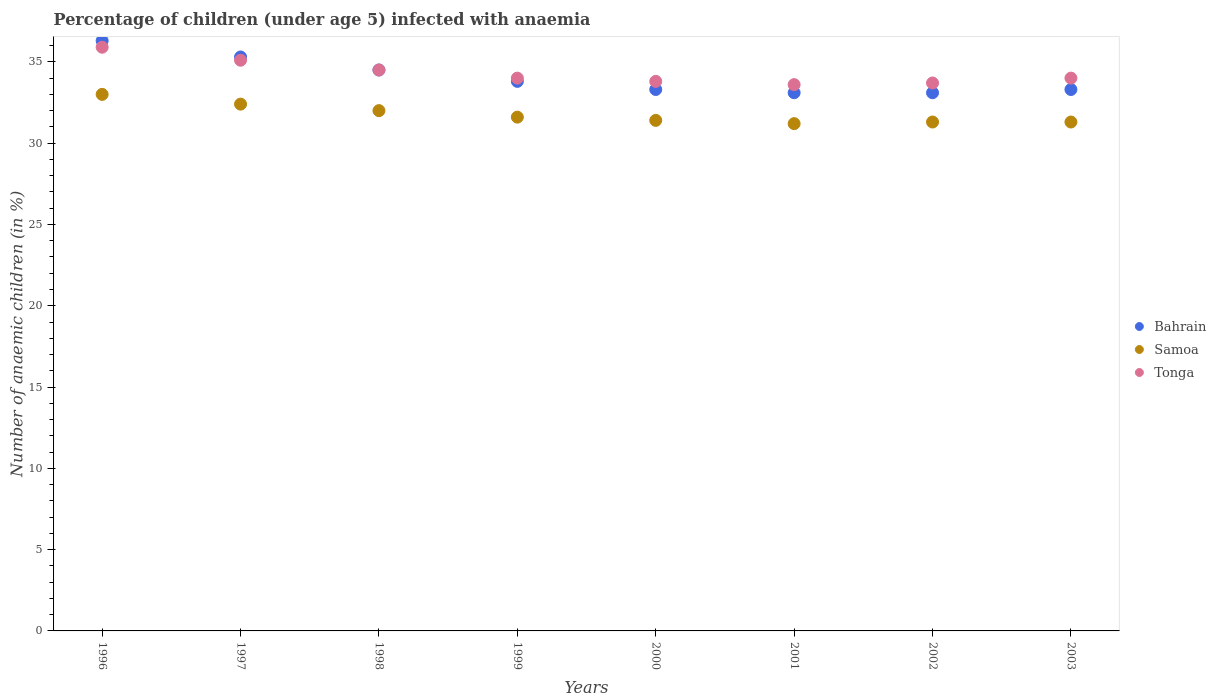What is the percentage of children infected with anaemia in in Bahrain in 1999?
Keep it short and to the point. 33.8. Across all years, what is the minimum percentage of children infected with anaemia in in Tonga?
Provide a short and direct response. 33.6. In which year was the percentage of children infected with anaemia in in Samoa maximum?
Provide a succinct answer. 1996. What is the total percentage of children infected with anaemia in in Bahrain in the graph?
Your answer should be very brief. 272.7. What is the difference between the percentage of children infected with anaemia in in Bahrain in 1996 and that in 1999?
Your answer should be very brief. 2.5. What is the difference between the percentage of children infected with anaemia in in Tonga in 1998 and the percentage of children infected with anaemia in in Samoa in 1997?
Ensure brevity in your answer.  2.1. What is the average percentage of children infected with anaemia in in Samoa per year?
Give a very brief answer. 31.77. In the year 2002, what is the difference between the percentage of children infected with anaemia in in Samoa and percentage of children infected with anaemia in in Tonga?
Offer a very short reply. -2.4. What is the ratio of the percentage of children infected with anaemia in in Bahrain in 1996 to that in 2003?
Your response must be concise. 1.09. Is the percentage of children infected with anaemia in in Bahrain in 1999 less than that in 2000?
Your answer should be compact. No. Is the difference between the percentage of children infected with anaemia in in Samoa in 1996 and 1998 greater than the difference between the percentage of children infected with anaemia in in Tonga in 1996 and 1998?
Make the answer very short. No. What is the difference between the highest and the second highest percentage of children infected with anaemia in in Bahrain?
Provide a succinct answer. 1. What is the difference between the highest and the lowest percentage of children infected with anaemia in in Bahrain?
Ensure brevity in your answer.  3.2. In how many years, is the percentage of children infected with anaemia in in Bahrain greater than the average percentage of children infected with anaemia in in Bahrain taken over all years?
Your answer should be very brief. 3. Is the sum of the percentage of children infected with anaemia in in Tonga in 1997 and 2000 greater than the maximum percentage of children infected with anaemia in in Samoa across all years?
Offer a very short reply. Yes. Does the percentage of children infected with anaemia in in Tonga monotonically increase over the years?
Your answer should be compact. No. Is the percentage of children infected with anaemia in in Tonga strictly less than the percentage of children infected with anaemia in in Bahrain over the years?
Offer a very short reply. No. What is the difference between two consecutive major ticks on the Y-axis?
Provide a succinct answer. 5. Are the values on the major ticks of Y-axis written in scientific E-notation?
Your answer should be very brief. No. Does the graph contain grids?
Give a very brief answer. No. How many legend labels are there?
Provide a succinct answer. 3. How are the legend labels stacked?
Your answer should be very brief. Vertical. What is the title of the graph?
Ensure brevity in your answer.  Percentage of children (under age 5) infected with anaemia. Does "Caribbean small states" appear as one of the legend labels in the graph?
Your answer should be compact. No. What is the label or title of the Y-axis?
Ensure brevity in your answer.  Number of anaemic children (in %). What is the Number of anaemic children (in %) in Bahrain in 1996?
Your response must be concise. 36.3. What is the Number of anaemic children (in %) of Samoa in 1996?
Your answer should be compact. 33. What is the Number of anaemic children (in %) in Tonga in 1996?
Give a very brief answer. 35.9. What is the Number of anaemic children (in %) in Bahrain in 1997?
Make the answer very short. 35.3. What is the Number of anaemic children (in %) in Samoa in 1997?
Your response must be concise. 32.4. What is the Number of anaemic children (in %) of Tonga in 1997?
Make the answer very short. 35.1. What is the Number of anaemic children (in %) in Bahrain in 1998?
Your answer should be compact. 34.5. What is the Number of anaemic children (in %) of Samoa in 1998?
Offer a terse response. 32. What is the Number of anaemic children (in %) of Tonga in 1998?
Ensure brevity in your answer.  34.5. What is the Number of anaemic children (in %) of Bahrain in 1999?
Give a very brief answer. 33.8. What is the Number of anaemic children (in %) of Samoa in 1999?
Keep it short and to the point. 31.6. What is the Number of anaemic children (in %) of Bahrain in 2000?
Make the answer very short. 33.3. What is the Number of anaemic children (in %) of Samoa in 2000?
Give a very brief answer. 31.4. What is the Number of anaemic children (in %) of Tonga in 2000?
Provide a succinct answer. 33.8. What is the Number of anaemic children (in %) in Bahrain in 2001?
Your answer should be very brief. 33.1. What is the Number of anaemic children (in %) of Samoa in 2001?
Offer a very short reply. 31.2. What is the Number of anaemic children (in %) of Tonga in 2001?
Ensure brevity in your answer.  33.6. What is the Number of anaemic children (in %) of Bahrain in 2002?
Provide a short and direct response. 33.1. What is the Number of anaemic children (in %) of Samoa in 2002?
Offer a terse response. 31.3. What is the Number of anaemic children (in %) of Tonga in 2002?
Your response must be concise. 33.7. What is the Number of anaemic children (in %) of Bahrain in 2003?
Your response must be concise. 33.3. What is the Number of anaemic children (in %) in Samoa in 2003?
Provide a short and direct response. 31.3. What is the Number of anaemic children (in %) in Tonga in 2003?
Offer a terse response. 34. Across all years, what is the maximum Number of anaemic children (in %) in Bahrain?
Provide a succinct answer. 36.3. Across all years, what is the maximum Number of anaemic children (in %) of Samoa?
Make the answer very short. 33. Across all years, what is the maximum Number of anaemic children (in %) in Tonga?
Ensure brevity in your answer.  35.9. Across all years, what is the minimum Number of anaemic children (in %) of Bahrain?
Your answer should be very brief. 33.1. Across all years, what is the minimum Number of anaemic children (in %) in Samoa?
Give a very brief answer. 31.2. Across all years, what is the minimum Number of anaemic children (in %) of Tonga?
Provide a succinct answer. 33.6. What is the total Number of anaemic children (in %) of Bahrain in the graph?
Offer a terse response. 272.7. What is the total Number of anaemic children (in %) of Samoa in the graph?
Provide a short and direct response. 254.2. What is the total Number of anaemic children (in %) of Tonga in the graph?
Keep it short and to the point. 274.6. What is the difference between the Number of anaemic children (in %) in Bahrain in 1996 and that in 1997?
Your answer should be compact. 1. What is the difference between the Number of anaemic children (in %) of Samoa in 1996 and that in 1997?
Your answer should be very brief. 0.6. What is the difference between the Number of anaemic children (in %) of Samoa in 1996 and that in 1998?
Keep it short and to the point. 1. What is the difference between the Number of anaemic children (in %) of Bahrain in 1996 and that in 1999?
Your answer should be very brief. 2.5. What is the difference between the Number of anaemic children (in %) of Tonga in 1996 and that in 1999?
Your response must be concise. 1.9. What is the difference between the Number of anaemic children (in %) of Bahrain in 1996 and that in 2000?
Keep it short and to the point. 3. What is the difference between the Number of anaemic children (in %) of Samoa in 1996 and that in 2000?
Offer a very short reply. 1.6. What is the difference between the Number of anaemic children (in %) in Bahrain in 1996 and that in 2001?
Keep it short and to the point. 3.2. What is the difference between the Number of anaemic children (in %) in Samoa in 1996 and that in 2001?
Your answer should be very brief. 1.8. What is the difference between the Number of anaemic children (in %) of Bahrain in 1996 and that in 2002?
Your response must be concise. 3.2. What is the difference between the Number of anaemic children (in %) in Tonga in 1997 and that in 1998?
Give a very brief answer. 0.6. What is the difference between the Number of anaemic children (in %) of Samoa in 1997 and that in 1999?
Your answer should be very brief. 0.8. What is the difference between the Number of anaemic children (in %) in Tonga in 1997 and that in 1999?
Offer a terse response. 1.1. What is the difference between the Number of anaemic children (in %) in Bahrain in 1997 and that in 2000?
Offer a very short reply. 2. What is the difference between the Number of anaemic children (in %) of Samoa in 1997 and that in 2000?
Your response must be concise. 1. What is the difference between the Number of anaemic children (in %) in Bahrain in 1997 and that in 2001?
Ensure brevity in your answer.  2.2. What is the difference between the Number of anaemic children (in %) of Samoa in 1997 and that in 2001?
Give a very brief answer. 1.2. What is the difference between the Number of anaemic children (in %) of Tonga in 1997 and that in 2001?
Keep it short and to the point. 1.5. What is the difference between the Number of anaemic children (in %) of Bahrain in 1997 and that in 2002?
Provide a succinct answer. 2.2. What is the difference between the Number of anaemic children (in %) in Samoa in 1997 and that in 2002?
Keep it short and to the point. 1.1. What is the difference between the Number of anaemic children (in %) of Tonga in 1997 and that in 2002?
Keep it short and to the point. 1.4. What is the difference between the Number of anaemic children (in %) in Bahrain in 1997 and that in 2003?
Your answer should be very brief. 2. What is the difference between the Number of anaemic children (in %) of Samoa in 1997 and that in 2003?
Give a very brief answer. 1.1. What is the difference between the Number of anaemic children (in %) of Tonga in 1997 and that in 2003?
Offer a terse response. 1.1. What is the difference between the Number of anaemic children (in %) of Bahrain in 1998 and that in 1999?
Your answer should be very brief. 0.7. What is the difference between the Number of anaemic children (in %) of Bahrain in 1998 and that in 2000?
Your answer should be compact. 1.2. What is the difference between the Number of anaemic children (in %) of Tonga in 1998 and that in 2000?
Give a very brief answer. 0.7. What is the difference between the Number of anaemic children (in %) of Bahrain in 1998 and that in 2001?
Offer a very short reply. 1.4. What is the difference between the Number of anaemic children (in %) of Samoa in 1998 and that in 2001?
Provide a short and direct response. 0.8. What is the difference between the Number of anaemic children (in %) of Tonga in 1998 and that in 2001?
Keep it short and to the point. 0.9. What is the difference between the Number of anaemic children (in %) in Bahrain in 1998 and that in 2002?
Your answer should be compact. 1.4. What is the difference between the Number of anaemic children (in %) of Samoa in 1998 and that in 2002?
Your answer should be very brief. 0.7. What is the difference between the Number of anaemic children (in %) in Tonga in 1998 and that in 2002?
Your answer should be compact. 0.8. What is the difference between the Number of anaemic children (in %) of Bahrain in 1999 and that in 2000?
Ensure brevity in your answer.  0.5. What is the difference between the Number of anaemic children (in %) of Samoa in 1999 and that in 2000?
Your response must be concise. 0.2. What is the difference between the Number of anaemic children (in %) in Tonga in 1999 and that in 2000?
Your answer should be very brief. 0.2. What is the difference between the Number of anaemic children (in %) in Bahrain in 1999 and that in 2001?
Make the answer very short. 0.7. What is the difference between the Number of anaemic children (in %) in Samoa in 1999 and that in 2002?
Offer a terse response. 0.3. What is the difference between the Number of anaemic children (in %) of Tonga in 1999 and that in 2002?
Your answer should be compact. 0.3. What is the difference between the Number of anaemic children (in %) of Samoa in 1999 and that in 2003?
Give a very brief answer. 0.3. What is the difference between the Number of anaemic children (in %) of Tonga in 2000 and that in 2001?
Give a very brief answer. 0.2. What is the difference between the Number of anaemic children (in %) of Bahrain in 2000 and that in 2002?
Make the answer very short. 0.2. What is the difference between the Number of anaemic children (in %) of Bahrain in 2000 and that in 2003?
Give a very brief answer. 0. What is the difference between the Number of anaemic children (in %) in Samoa in 2000 and that in 2003?
Your answer should be very brief. 0.1. What is the difference between the Number of anaemic children (in %) in Bahrain in 2001 and that in 2002?
Offer a very short reply. 0. What is the difference between the Number of anaemic children (in %) of Tonga in 2001 and that in 2002?
Offer a terse response. -0.1. What is the difference between the Number of anaemic children (in %) in Samoa in 2001 and that in 2003?
Provide a short and direct response. -0.1. What is the difference between the Number of anaemic children (in %) in Bahrain in 2002 and that in 2003?
Make the answer very short. -0.2. What is the difference between the Number of anaemic children (in %) in Samoa in 2002 and that in 2003?
Keep it short and to the point. 0. What is the difference between the Number of anaemic children (in %) in Tonga in 2002 and that in 2003?
Give a very brief answer. -0.3. What is the difference between the Number of anaemic children (in %) in Bahrain in 1996 and the Number of anaemic children (in %) in Tonga in 1997?
Your response must be concise. 1.2. What is the difference between the Number of anaemic children (in %) of Bahrain in 1996 and the Number of anaemic children (in %) of Samoa in 1998?
Offer a very short reply. 4.3. What is the difference between the Number of anaemic children (in %) of Samoa in 1996 and the Number of anaemic children (in %) of Tonga in 1998?
Keep it short and to the point. -1.5. What is the difference between the Number of anaemic children (in %) in Samoa in 1996 and the Number of anaemic children (in %) in Tonga in 2000?
Your answer should be very brief. -0.8. What is the difference between the Number of anaemic children (in %) in Samoa in 1996 and the Number of anaemic children (in %) in Tonga in 2002?
Offer a terse response. -0.7. What is the difference between the Number of anaemic children (in %) in Samoa in 1996 and the Number of anaemic children (in %) in Tonga in 2003?
Your answer should be very brief. -1. What is the difference between the Number of anaemic children (in %) in Bahrain in 1997 and the Number of anaemic children (in %) in Tonga in 1998?
Provide a succinct answer. 0.8. What is the difference between the Number of anaemic children (in %) of Samoa in 1997 and the Number of anaemic children (in %) of Tonga in 1998?
Keep it short and to the point. -2.1. What is the difference between the Number of anaemic children (in %) of Bahrain in 1997 and the Number of anaemic children (in %) of Tonga in 1999?
Provide a succinct answer. 1.3. What is the difference between the Number of anaemic children (in %) of Samoa in 1997 and the Number of anaemic children (in %) of Tonga in 1999?
Ensure brevity in your answer.  -1.6. What is the difference between the Number of anaemic children (in %) in Bahrain in 1997 and the Number of anaemic children (in %) in Tonga in 2000?
Your answer should be compact. 1.5. What is the difference between the Number of anaemic children (in %) of Bahrain in 1997 and the Number of anaemic children (in %) of Samoa in 2001?
Offer a terse response. 4.1. What is the difference between the Number of anaemic children (in %) in Bahrain in 1997 and the Number of anaemic children (in %) in Tonga in 2001?
Provide a succinct answer. 1.7. What is the difference between the Number of anaemic children (in %) of Samoa in 1997 and the Number of anaemic children (in %) of Tonga in 2001?
Offer a terse response. -1.2. What is the difference between the Number of anaemic children (in %) in Samoa in 1997 and the Number of anaemic children (in %) in Tonga in 2002?
Offer a very short reply. -1.3. What is the difference between the Number of anaemic children (in %) in Bahrain in 1997 and the Number of anaemic children (in %) in Samoa in 2003?
Offer a terse response. 4. What is the difference between the Number of anaemic children (in %) in Samoa in 1997 and the Number of anaemic children (in %) in Tonga in 2003?
Give a very brief answer. -1.6. What is the difference between the Number of anaemic children (in %) in Bahrain in 1998 and the Number of anaemic children (in %) in Samoa in 1999?
Provide a succinct answer. 2.9. What is the difference between the Number of anaemic children (in %) in Bahrain in 1998 and the Number of anaemic children (in %) in Tonga in 1999?
Offer a terse response. 0.5. What is the difference between the Number of anaemic children (in %) in Samoa in 1998 and the Number of anaemic children (in %) in Tonga in 1999?
Offer a very short reply. -2. What is the difference between the Number of anaemic children (in %) in Bahrain in 1998 and the Number of anaemic children (in %) in Tonga in 2000?
Offer a very short reply. 0.7. What is the difference between the Number of anaemic children (in %) in Bahrain in 1998 and the Number of anaemic children (in %) in Samoa in 2001?
Provide a succinct answer. 3.3. What is the difference between the Number of anaemic children (in %) of Bahrain in 1998 and the Number of anaemic children (in %) of Tonga in 2002?
Ensure brevity in your answer.  0.8. What is the difference between the Number of anaemic children (in %) of Samoa in 1998 and the Number of anaemic children (in %) of Tonga in 2002?
Give a very brief answer. -1.7. What is the difference between the Number of anaemic children (in %) in Bahrain in 1998 and the Number of anaemic children (in %) in Samoa in 2003?
Give a very brief answer. 3.2. What is the difference between the Number of anaemic children (in %) of Bahrain in 1998 and the Number of anaemic children (in %) of Tonga in 2003?
Offer a terse response. 0.5. What is the difference between the Number of anaemic children (in %) in Bahrain in 1999 and the Number of anaemic children (in %) in Samoa in 2000?
Keep it short and to the point. 2.4. What is the difference between the Number of anaemic children (in %) of Bahrain in 1999 and the Number of anaemic children (in %) of Tonga in 2001?
Your answer should be very brief. 0.2. What is the difference between the Number of anaemic children (in %) in Samoa in 1999 and the Number of anaemic children (in %) in Tonga in 2001?
Your response must be concise. -2. What is the difference between the Number of anaemic children (in %) in Bahrain in 1999 and the Number of anaemic children (in %) in Samoa in 2002?
Offer a terse response. 2.5. What is the difference between the Number of anaemic children (in %) of Samoa in 1999 and the Number of anaemic children (in %) of Tonga in 2002?
Provide a short and direct response. -2.1. What is the difference between the Number of anaemic children (in %) of Bahrain in 1999 and the Number of anaemic children (in %) of Samoa in 2003?
Your answer should be very brief. 2.5. What is the difference between the Number of anaemic children (in %) of Samoa in 1999 and the Number of anaemic children (in %) of Tonga in 2003?
Offer a very short reply. -2.4. What is the difference between the Number of anaemic children (in %) of Bahrain in 2000 and the Number of anaemic children (in %) of Tonga in 2001?
Ensure brevity in your answer.  -0.3. What is the difference between the Number of anaemic children (in %) in Samoa in 2000 and the Number of anaemic children (in %) in Tonga in 2002?
Your response must be concise. -2.3. What is the difference between the Number of anaemic children (in %) in Bahrain in 2000 and the Number of anaemic children (in %) in Samoa in 2003?
Offer a very short reply. 2. What is the difference between the Number of anaemic children (in %) of Samoa in 2000 and the Number of anaemic children (in %) of Tonga in 2003?
Provide a succinct answer. -2.6. What is the difference between the Number of anaemic children (in %) of Bahrain in 2001 and the Number of anaemic children (in %) of Samoa in 2002?
Keep it short and to the point. 1.8. What is the difference between the Number of anaemic children (in %) in Samoa in 2001 and the Number of anaemic children (in %) in Tonga in 2002?
Provide a short and direct response. -2.5. What is the difference between the Number of anaemic children (in %) in Samoa in 2001 and the Number of anaemic children (in %) in Tonga in 2003?
Ensure brevity in your answer.  -2.8. What is the difference between the Number of anaemic children (in %) of Bahrain in 2002 and the Number of anaemic children (in %) of Samoa in 2003?
Offer a very short reply. 1.8. What is the difference between the Number of anaemic children (in %) in Bahrain in 2002 and the Number of anaemic children (in %) in Tonga in 2003?
Offer a terse response. -0.9. What is the average Number of anaemic children (in %) of Bahrain per year?
Keep it short and to the point. 34.09. What is the average Number of anaemic children (in %) of Samoa per year?
Provide a succinct answer. 31.77. What is the average Number of anaemic children (in %) of Tonga per year?
Provide a succinct answer. 34.33. In the year 1996, what is the difference between the Number of anaemic children (in %) of Samoa and Number of anaemic children (in %) of Tonga?
Ensure brevity in your answer.  -2.9. In the year 1998, what is the difference between the Number of anaemic children (in %) of Samoa and Number of anaemic children (in %) of Tonga?
Offer a terse response. -2.5. In the year 1999, what is the difference between the Number of anaemic children (in %) in Bahrain and Number of anaemic children (in %) in Samoa?
Your response must be concise. 2.2. In the year 1999, what is the difference between the Number of anaemic children (in %) of Samoa and Number of anaemic children (in %) of Tonga?
Provide a succinct answer. -2.4. In the year 2001, what is the difference between the Number of anaemic children (in %) in Samoa and Number of anaemic children (in %) in Tonga?
Offer a terse response. -2.4. In the year 2002, what is the difference between the Number of anaemic children (in %) in Bahrain and Number of anaemic children (in %) in Tonga?
Your response must be concise. -0.6. In the year 2003, what is the difference between the Number of anaemic children (in %) of Bahrain and Number of anaemic children (in %) of Samoa?
Your answer should be compact. 2. In the year 2003, what is the difference between the Number of anaemic children (in %) in Samoa and Number of anaemic children (in %) in Tonga?
Offer a very short reply. -2.7. What is the ratio of the Number of anaemic children (in %) of Bahrain in 1996 to that in 1997?
Offer a terse response. 1.03. What is the ratio of the Number of anaemic children (in %) in Samoa in 1996 to that in 1997?
Offer a very short reply. 1.02. What is the ratio of the Number of anaemic children (in %) in Tonga in 1996 to that in 1997?
Ensure brevity in your answer.  1.02. What is the ratio of the Number of anaemic children (in %) of Bahrain in 1996 to that in 1998?
Offer a terse response. 1.05. What is the ratio of the Number of anaemic children (in %) in Samoa in 1996 to that in 1998?
Ensure brevity in your answer.  1.03. What is the ratio of the Number of anaemic children (in %) in Tonga in 1996 to that in 1998?
Provide a succinct answer. 1.04. What is the ratio of the Number of anaemic children (in %) in Bahrain in 1996 to that in 1999?
Your answer should be very brief. 1.07. What is the ratio of the Number of anaemic children (in %) of Samoa in 1996 to that in 1999?
Your answer should be very brief. 1.04. What is the ratio of the Number of anaemic children (in %) of Tonga in 1996 to that in 1999?
Provide a succinct answer. 1.06. What is the ratio of the Number of anaemic children (in %) of Bahrain in 1996 to that in 2000?
Your answer should be compact. 1.09. What is the ratio of the Number of anaemic children (in %) in Samoa in 1996 to that in 2000?
Ensure brevity in your answer.  1.05. What is the ratio of the Number of anaemic children (in %) in Tonga in 1996 to that in 2000?
Give a very brief answer. 1.06. What is the ratio of the Number of anaemic children (in %) of Bahrain in 1996 to that in 2001?
Keep it short and to the point. 1.1. What is the ratio of the Number of anaemic children (in %) of Samoa in 1996 to that in 2001?
Your answer should be very brief. 1.06. What is the ratio of the Number of anaemic children (in %) in Tonga in 1996 to that in 2001?
Make the answer very short. 1.07. What is the ratio of the Number of anaemic children (in %) of Bahrain in 1996 to that in 2002?
Your answer should be compact. 1.1. What is the ratio of the Number of anaemic children (in %) of Samoa in 1996 to that in 2002?
Your answer should be compact. 1.05. What is the ratio of the Number of anaemic children (in %) in Tonga in 1996 to that in 2002?
Provide a succinct answer. 1.07. What is the ratio of the Number of anaemic children (in %) in Bahrain in 1996 to that in 2003?
Provide a short and direct response. 1.09. What is the ratio of the Number of anaemic children (in %) of Samoa in 1996 to that in 2003?
Provide a succinct answer. 1.05. What is the ratio of the Number of anaemic children (in %) of Tonga in 1996 to that in 2003?
Ensure brevity in your answer.  1.06. What is the ratio of the Number of anaemic children (in %) of Bahrain in 1997 to that in 1998?
Ensure brevity in your answer.  1.02. What is the ratio of the Number of anaemic children (in %) of Samoa in 1997 to that in 1998?
Ensure brevity in your answer.  1.01. What is the ratio of the Number of anaemic children (in %) in Tonga in 1997 to that in 1998?
Offer a very short reply. 1.02. What is the ratio of the Number of anaemic children (in %) in Bahrain in 1997 to that in 1999?
Keep it short and to the point. 1.04. What is the ratio of the Number of anaemic children (in %) of Samoa in 1997 to that in 1999?
Your answer should be very brief. 1.03. What is the ratio of the Number of anaemic children (in %) in Tonga in 1997 to that in 1999?
Offer a terse response. 1.03. What is the ratio of the Number of anaemic children (in %) of Bahrain in 1997 to that in 2000?
Provide a short and direct response. 1.06. What is the ratio of the Number of anaemic children (in %) of Samoa in 1997 to that in 2000?
Your answer should be very brief. 1.03. What is the ratio of the Number of anaemic children (in %) of Tonga in 1997 to that in 2000?
Your response must be concise. 1.04. What is the ratio of the Number of anaemic children (in %) of Bahrain in 1997 to that in 2001?
Keep it short and to the point. 1.07. What is the ratio of the Number of anaemic children (in %) in Samoa in 1997 to that in 2001?
Your response must be concise. 1.04. What is the ratio of the Number of anaemic children (in %) in Tonga in 1997 to that in 2001?
Give a very brief answer. 1.04. What is the ratio of the Number of anaemic children (in %) in Bahrain in 1997 to that in 2002?
Your answer should be compact. 1.07. What is the ratio of the Number of anaemic children (in %) of Samoa in 1997 to that in 2002?
Your answer should be very brief. 1.04. What is the ratio of the Number of anaemic children (in %) of Tonga in 1997 to that in 2002?
Ensure brevity in your answer.  1.04. What is the ratio of the Number of anaemic children (in %) of Bahrain in 1997 to that in 2003?
Give a very brief answer. 1.06. What is the ratio of the Number of anaemic children (in %) in Samoa in 1997 to that in 2003?
Make the answer very short. 1.04. What is the ratio of the Number of anaemic children (in %) in Tonga in 1997 to that in 2003?
Ensure brevity in your answer.  1.03. What is the ratio of the Number of anaemic children (in %) in Bahrain in 1998 to that in 1999?
Keep it short and to the point. 1.02. What is the ratio of the Number of anaemic children (in %) of Samoa in 1998 to that in 1999?
Provide a short and direct response. 1.01. What is the ratio of the Number of anaemic children (in %) in Tonga in 1998 to that in 1999?
Offer a very short reply. 1.01. What is the ratio of the Number of anaemic children (in %) in Bahrain in 1998 to that in 2000?
Ensure brevity in your answer.  1.04. What is the ratio of the Number of anaemic children (in %) of Samoa in 1998 to that in 2000?
Offer a very short reply. 1.02. What is the ratio of the Number of anaemic children (in %) of Tonga in 1998 to that in 2000?
Offer a very short reply. 1.02. What is the ratio of the Number of anaemic children (in %) in Bahrain in 1998 to that in 2001?
Offer a very short reply. 1.04. What is the ratio of the Number of anaemic children (in %) in Samoa in 1998 to that in 2001?
Provide a short and direct response. 1.03. What is the ratio of the Number of anaemic children (in %) in Tonga in 1998 to that in 2001?
Keep it short and to the point. 1.03. What is the ratio of the Number of anaemic children (in %) of Bahrain in 1998 to that in 2002?
Your response must be concise. 1.04. What is the ratio of the Number of anaemic children (in %) of Samoa in 1998 to that in 2002?
Your answer should be compact. 1.02. What is the ratio of the Number of anaemic children (in %) of Tonga in 1998 to that in 2002?
Keep it short and to the point. 1.02. What is the ratio of the Number of anaemic children (in %) of Bahrain in 1998 to that in 2003?
Your answer should be very brief. 1.04. What is the ratio of the Number of anaemic children (in %) in Samoa in 1998 to that in 2003?
Provide a short and direct response. 1.02. What is the ratio of the Number of anaemic children (in %) in Tonga in 1998 to that in 2003?
Make the answer very short. 1.01. What is the ratio of the Number of anaemic children (in %) in Samoa in 1999 to that in 2000?
Your answer should be compact. 1.01. What is the ratio of the Number of anaemic children (in %) of Tonga in 1999 to that in 2000?
Offer a terse response. 1.01. What is the ratio of the Number of anaemic children (in %) of Bahrain in 1999 to that in 2001?
Make the answer very short. 1.02. What is the ratio of the Number of anaemic children (in %) in Samoa in 1999 to that in 2001?
Your answer should be compact. 1.01. What is the ratio of the Number of anaemic children (in %) of Tonga in 1999 to that in 2001?
Provide a short and direct response. 1.01. What is the ratio of the Number of anaemic children (in %) in Bahrain in 1999 to that in 2002?
Ensure brevity in your answer.  1.02. What is the ratio of the Number of anaemic children (in %) of Samoa in 1999 to that in 2002?
Your response must be concise. 1.01. What is the ratio of the Number of anaemic children (in %) in Tonga in 1999 to that in 2002?
Make the answer very short. 1.01. What is the ratio of the Number of anaemic children (in %) of Bahrain in 1999 to that in 2003?
Ensure brevity in your answer.  1.01. What is the ratio of the Number of anaemic children (in %) of Samoa in 1999 to that in 2003?
Your answer should be compact. 1.01. What is the ratio of the Number of anaemic children (in %) in Tonga in 1999 to that in 2003?
Provide a succinct answer. 1. What is the ratio of the Number of anaemic children (in %) of Samoa in 2000 to that in 2001?
Make the answer very short. 1.01. What is the ratio of the Number of anaemic children (in %) in Bahrain in 2000 to that in 2002?
Provide a short and direct response. 1.01. What is the ratio of the Number of anaemic children (in %) of Samoa in 2000 to that in 2002?
Make the answer very short. 1. What is the ratio of the Number of anaemic children (in %) of Bahrain in 2000 to that in 2003?
Your answer should be very brief. 1. What is the ratio of the Number of anaemic children (in %) in Samoa in 2000 to that in 2003?
Ensure brevity in your answer.  1. What is the ratio of the Number of anaemic children (in %) in Bahrain in 2001 to that in 2002?
Your response must be concise. 1. What is the ratio of the Number of anaemic children (in %) of Samoa in 2001 to that in 2002?
Offer a very short reply. 1. What is the ratio of the Number of anaemic children (in %) of Tonga in 2001 to that in 2002?
Give a very brief answer. 1. What is the ratio of the Number of anaemic children (in %) in Bahrain in 2001 to that in 2003?
Your answer should be very brief. 0.99. What is the ratio of the Number of anaemic children (in %) in Bahrain in 2002 to that in 2003?
Provide a short and direct response. 0.99. What is the ratio of the Number of anaemic children (in %) of Samoa in 2002 to that in 2003?
Your response must be concise. 1. What is the difference between the highest and the second highest Number of anaemic children (in %) of Samoa?
Your answer should be very brief. 0.6. What is the difference between the highest and the lowest Number of anaemic children (in %) in Samoa?
Offer a very short reply. 1.8. 